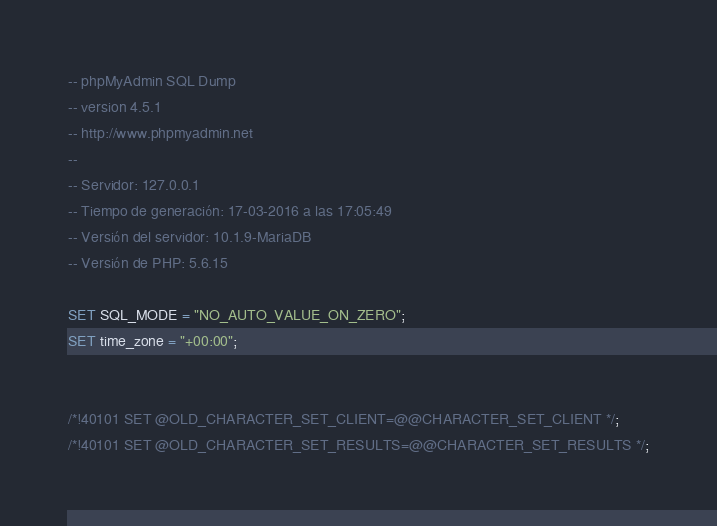<code> <loc_0><loc_0><loc_500><loc_500><_SQL_>-- phpMyAdmin SQL Dump
-- version 4.5.1
-- http://www.phpmyadmin.net
--
-- Servidor: 127.0.0.1
-- Tiempo de generación: 17-03-2016 a las 17:05:49
-- Versión del servidor: 10.1.9-MariaDB
-- Versión de PHP: 5.6.15

SET SQL_MODE = "NO_AUTO_VALUE_ON_ZERO";
SET time_zone = "+00:00";


/*!40101 SET @OLD_CHARACTER_SET_CLIENT=@@CHARACTER_SET_CLIENT */;
/*!40101 SET @OLD_CHARACTER_SET_RESULTS=@@CHARACTER_SET_RESULTS */;</code> 